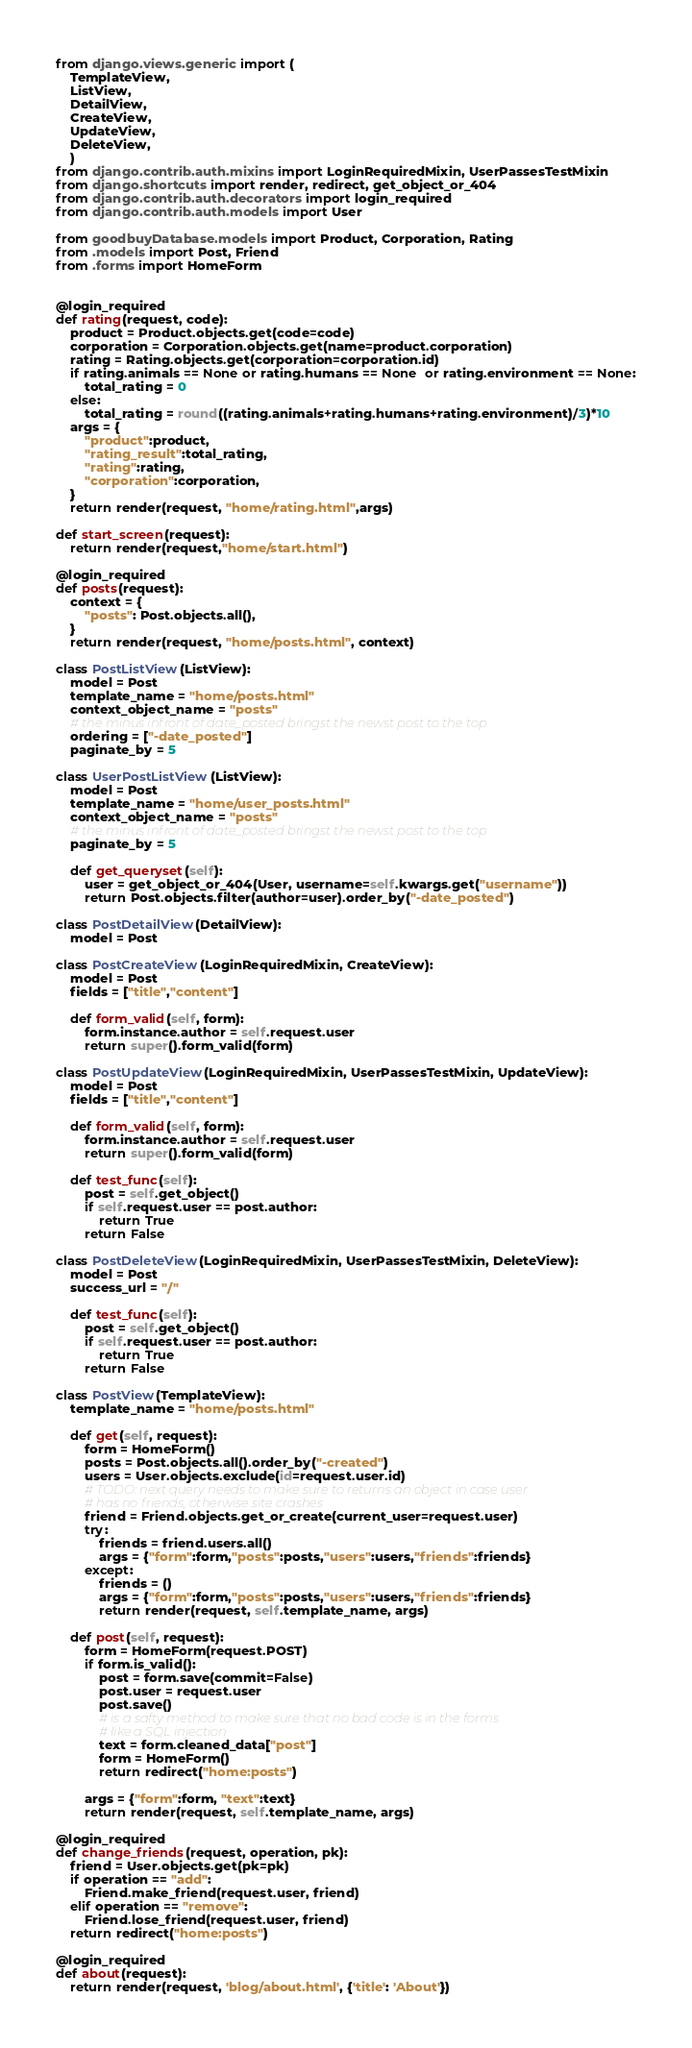<code> <loc_0><loc_0><loc_500><loc_500><_Python_>from django.views.generic import (
    TemplateView,
    ListView,
    DetailView,
    CreateView,
    UpdateView,
    DeleteView,
    )
from django.contrib.auth.mixins import LoginRequiredMixin, UserPassesTestMixin
from django.shortcuts import render, redirect, get_object_or_404
from django.contrib.auth.decorators import login_required
from django.contrib.auth.models import User

from goodbuyDatabase.models import Product, Corporation, Rating
from .models import Post, Friend
from .forms import HomeForm


@login_required
def rating(request, code):
    product = Product.objects.get(code=code)
    corporation = Corporation.objects.get(name=product.corporation)
    rating = Rating.objects.get(corporation=corporation.id)
    if rating.animals == None or rating.humans == None  or rating.environment == None:
        total_rating = 0
    else:
        total_rating = round((rating.animals+rating.humans+rating.environment)/3)*10
    args = {
        "product":product,
        "rating_result":total_rating,
        "rating":rating,
        "corporation":corporation,
    }
    return render(request, "home/rating.html",args)

def start_screen(request):
    return render(request,"home/start.html")

@login_required
def posts(request):
    context = {
        "posts": Post.objects.all(),
    }
    return render(request, "home/posts.html", context)

class PostListView(ListView):
    model = Post
    template_name = "home/posts.html"
    context_object_name = "posts"
    # the minus infront of date_posted bringst the newst post to the top
    ordering = ["-date_posted"]
    paginate_by = 5

class UserPostListView(ListView):
    model = Post
    template_name = "home/user_posts.html"
    context_object_name = "posts"
    # the minus infront of date_posted bringst the newst post to the top
    paginate_by = 5

    def get_queryset(self):
        user = get_object_or_404(User, username=self.kwargs.get("username"))
        return Post.objects.filter(author=user).order_by("-date_posted")

class PostDetailView(DetailView):
    model = Post

class PostCreateView(LoginRequiredMixin, CreateView):
    model = Post
    fields = ["title","content"]

    def form_valid(self, form):
        form.instance.author = self.request.user
        return super().form_valid(form)

class PostUpdateView(LoginRequiredMixin, UserPassesTestMixin, UpdateView):
    model = Post
    fields = ["title","content"]

    def form_valid(self, form):
        form.instance.author = self.request.user
        return super().form_valid(form)

    def test_func(self):
        post = self.get_object()
        if self.request.user == post.author:
            return True
        return False

class PostDeleteView(LoginRequiredMixin, UserPassesTestMixin, DeleteView):
    model = Post
    success_url = "/"

    def test_func(self):
        post = self.get_object()
        if self.request.user == post.author:
            return True
        return False

class PostView(TemplateView):
    template_name = "home/posts.html"

    def get(self, request):
        form = HomeForm()
        posts = Post.objects.all().order_by("-created")
        users = User.objects.exclude(id=request.user.id)
        # TODO: next query needs to make sure to returns an object in case user
        # has no friends, otherwise site crashes
        friend = Friend.objects.get_or_create(current_user=request.user)
        try:
            friends = friend.users.all()
            args = {"form":form,"posts":posts,"users":users,"friends":friends}
        except:
            friends = ()
            args = {"form":form,"posts":posts,"users":users,"friends":friends}
            return render(request, self.template_name, args)

    def post(self, request):
        form = HomeForm(request.POST)
        if form.is_valid():
            post = form.save(commit=False)
            post.user = request.user
            post.save()
            # is a safty method to make sure that no bad code is in the forms
            # like a SQL injection
            text = form.cleaned_data["post"]
            form = HomeForm()
            return redirect("home:posts")

        args = {"form":form, "text":text}
        return render(request, self.template_name, args)

@login_required
def change_friends(request, operation, pk):
    friend = User.objects.get(pk=pk)
    if operation == "add":
        Friend.make_friend(request.user, friend)
    elif operation == "remove":
        Friend.lose_friend(request.user, friend)
    return redirect("home:posts")

@login_required
def about(request):
    return render(request, 'blog/about.html', {'title': 'About'})
</code> 